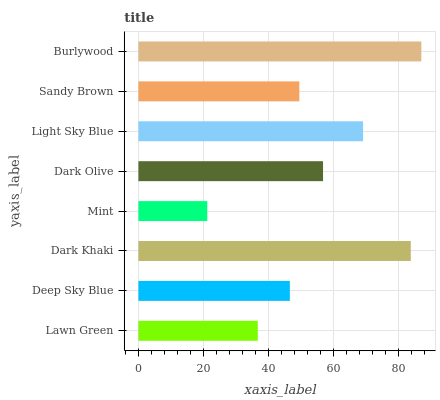Is Mint the minimum?
Answer yes or no. Yes. Is Burlywood the maximum?
Answer yes or no. Yes. Is Deep Sky Blue the minimum?
Answer yes or no. No. Is Deep Sky Blue the maximum?
Answer yes or no. No. Is Deep Sky Blue greater than Lawn Green?
Answer yes or no. Yes. Is Lawn Green less than Deep Sky Blue?
Answer yes or no. Yes. Is Lawn Green greater than Deep Sky Blue?
Answer yes or no. No. Is Deep Sky Blue less than Lawn Green?
Answer yes or no. No. Is Dark Olive the high median?
Answer yes or no. Yes. Is Sandy Brown the low median?
Answer yes or no. Yes. Is Sandy Brown the high median?
Answer yes or no. No. Is Dark Olive the low median?
Answer yes or no. No. 